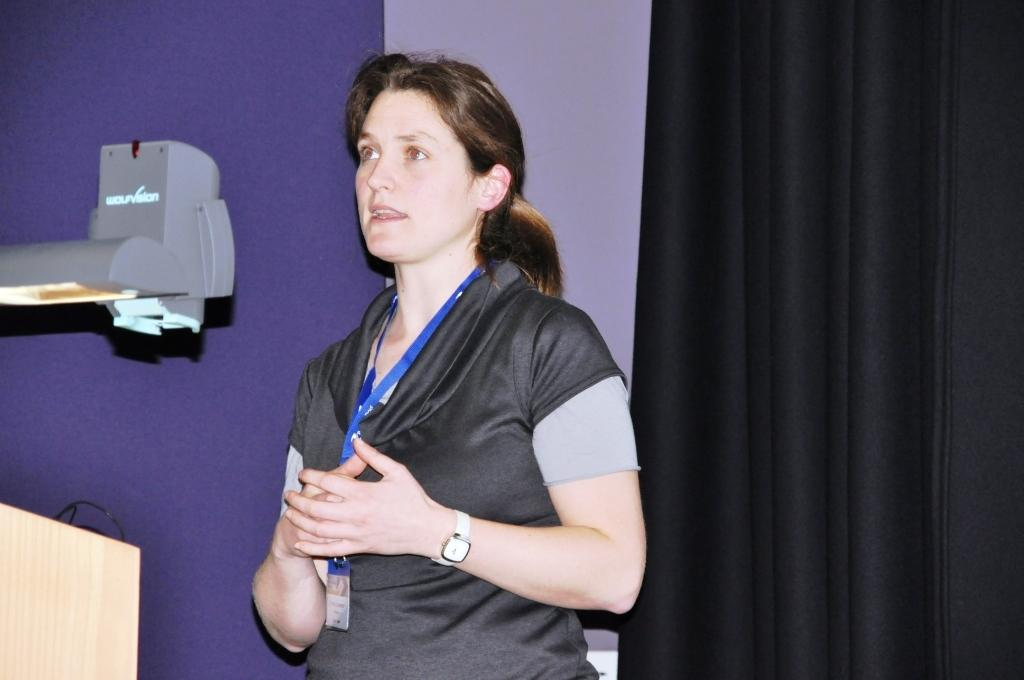What is the woman in the image doing? The woman is standing and talking in the image. What can be seen on the left side of the image? There is a wire on a podium on the left side of the image. What is the source of illumination in the image? There is a light in the image. What type of object is present in the image? There is a device in the image. What is located at the back of the image? There is a curtain at the back of the image. What type of bushes can be seen growing in the image? There are no bushes present in the image. 